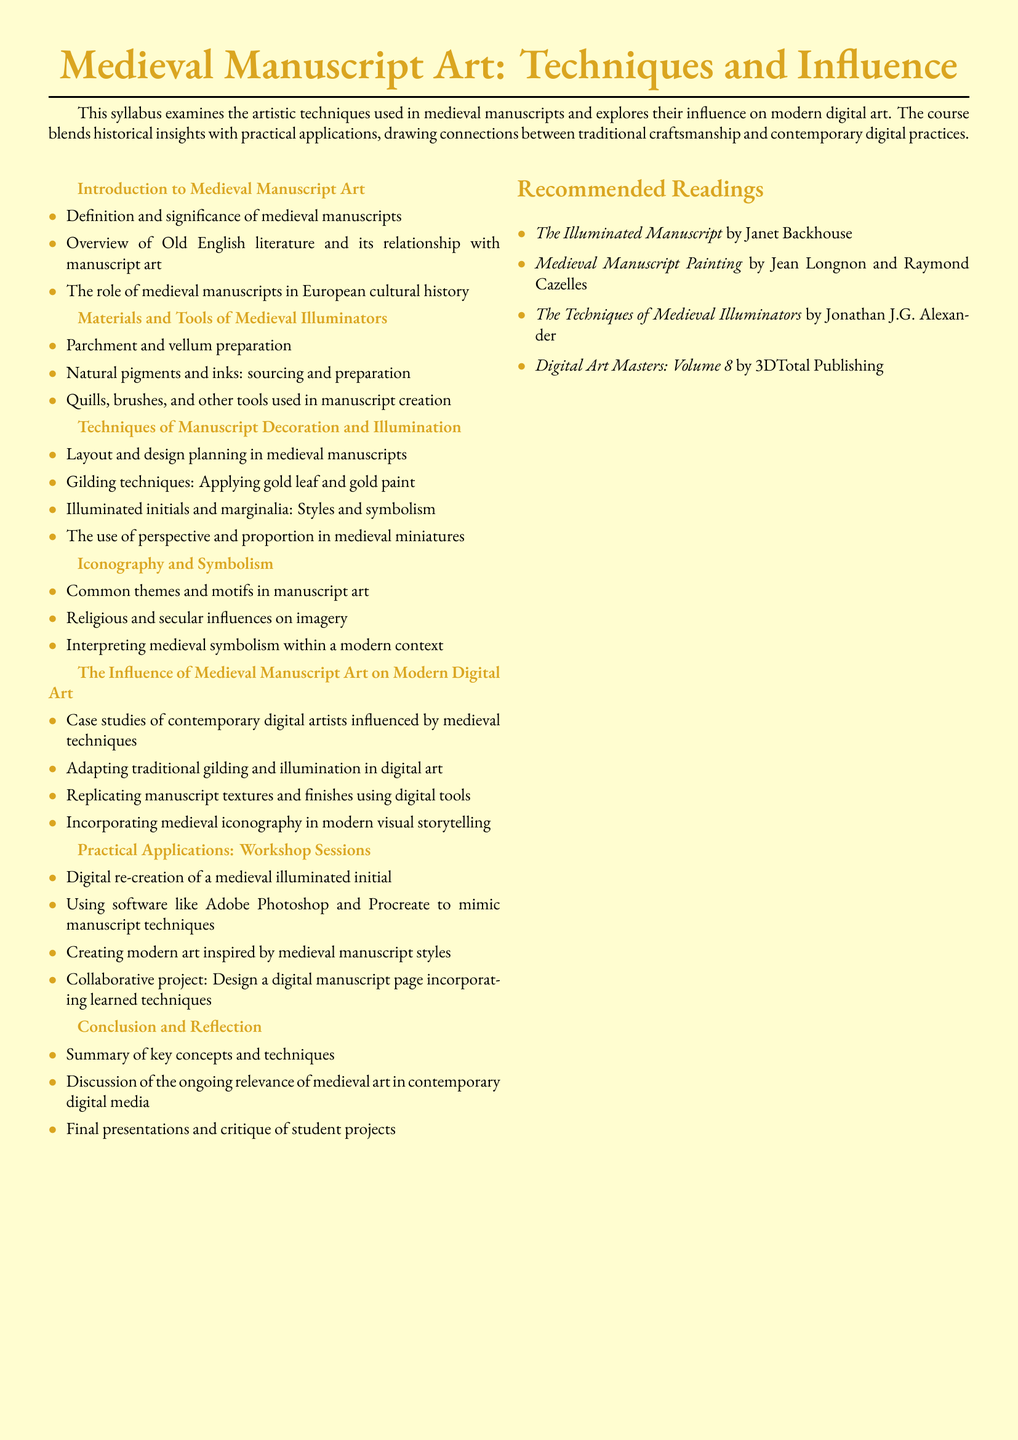what is the title of the syllabus? The title is clearly stated at the top of the document, highlighting the main focus of the course.
Answer: Medieval Manuscript Art: Techniques and Influence how many modules are listed in the syllabus? The syllabus includes a total of six modules that address different topics related to medieval manuscript art.
Answer: 6 who is the author of the recommended reading titled "The Techniques of Medieval Illuminators"? This book is listed among the recommended readings, indicating the author's expertise in the subject area.
Answer: Jonathan J.G. Alexander what technique involves applying gold leaf and gold paint? This technique is specifically mentioned in one of the modules as a method of manuscript decoration and illustration.
Answer: Gilding techniques which software is suggested for mimicking manuscript techniques? The syllabus identifies specific software tools that students can use for practical applications in the course.
Answer: Adobe Photoshop and Procreate name one common theme in manuscript art. This is discussed in the module about iconography and symbolism, focusing on the recurrent motifs found in medieval manuscripts.
Answer: Common themes and motifs what is one aim of the practical applications module? This module is designed to provide hands-on experience with techniques learned throughout the course.
Answer: Design a digital manuscript page which emotion is discussed in the conclusion and reflection module? The last module encourages students to contemplate the lasting impressions and current relevance of medieval art.
Answer: Ongoing relevance 